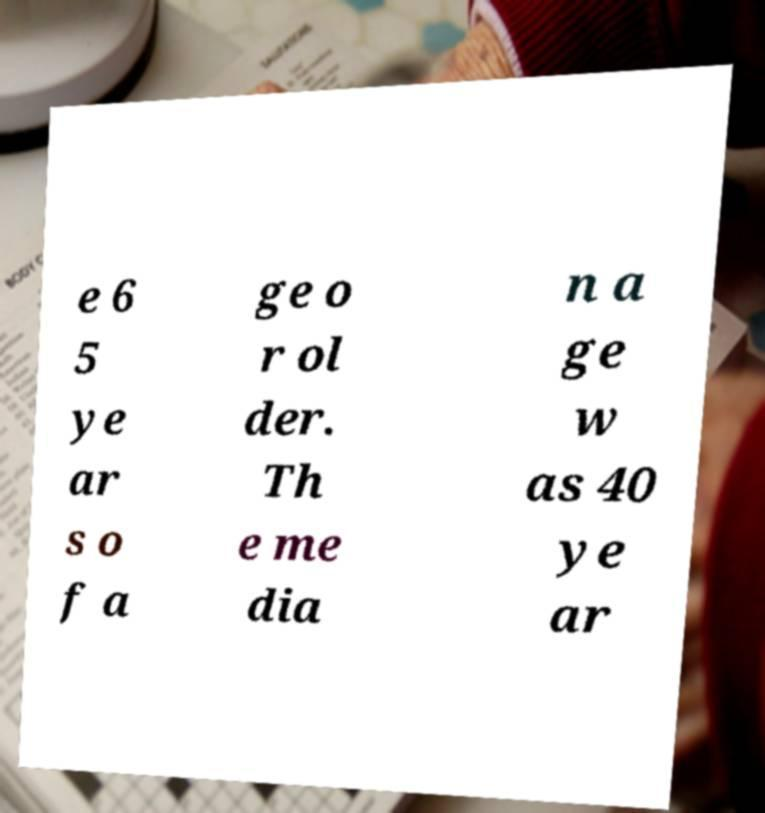There's text embedded in this image that I need extracted. Can you transcribe it verbatim? e 6 5 ye ar s o f a ge o r ol der. Th e me dia n a ge w as 40 ye ar 